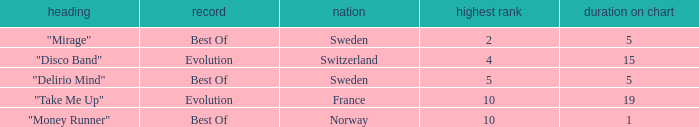What is the weeks on chart for the single from france? 19.0. 